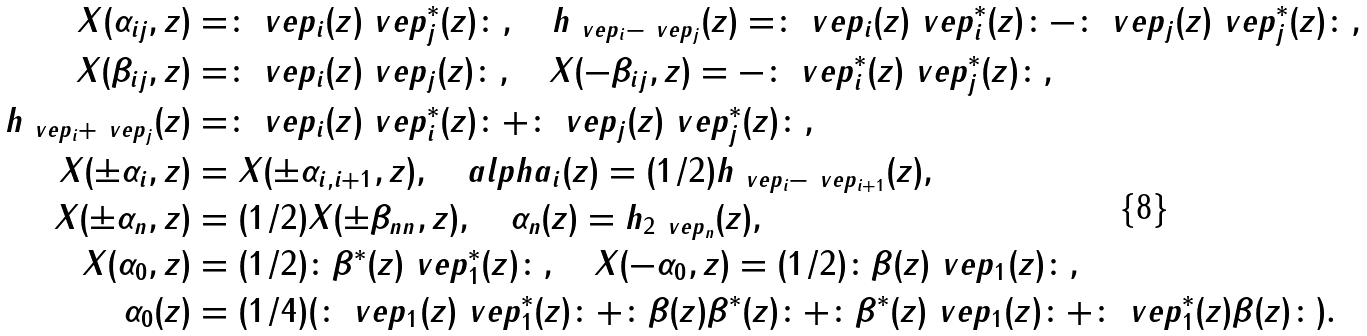Convert formula to latex. <formula><loc_0><loc_0><loc_500><loc_500>X ( \alpha _ { i j } , z ) & = \colon \ v e p _ { i } ( z ) \ v e p _ { j } ^ { * } ( z ) \colon , \quad h _ { \ v e p _ { i } - \ v e p _ { j } } ( z ) = \colon \ v e p _ { i } ( z ) \ v e p _ { i } ^ { * } ( z ) \colon - \colon \ v e p _ { j } ( z ) \ v e p _ { j } ^ { * } ( z ) \colon , \\ X ( \beta _ { i j } , z ) & = \colon \ v e p _ { i } ( z ) \ v e p _ { j } ( z ) \colon , \quad X ( - \beta _ { i j } , z ) = - \colon \ v e p _ { i } ^ { * } ( z ) \ v e p _ { j } ^ { * } ( z ) \colon , \\ h _ { \ v e p _ { i } + \ v e p _ { j } } ( z ) & = \colon \ v e p _ { i } ( z ) \ v e p _ { i } ^ { * } ( z ) \colon + \colon \ v e p _ { j } ( z ) \ v e p _ { j } ^ { * } ( z ) \colon , \\ X ( \pm \alpha _ { i } , z ) & = X ( \pm \alpha _ { i , i + 1 } , z ) , \quad a l p h a _ { i } ( z ) = ( 1 / 2 ) h _ { \ v e p _ { i } - \ v e p _ { i + 1 } } ( z ) , \\ X ( \pm \alpha _ { n } , z ) & = ( 1 / 2 ) X ( \pm \beta _ { n n } , z ) , \quad \alpha _ { n } ( z ) = h _ { 2 \ v e p _ { n } } ( z ) , \\ X ( \alpha _ { 0 } , z ) & = ( 1 / 2 ) \colon \beta ^ { * } ( z ) \ v e p _ { 1 } ^ { * } ( z ) \colon , \quad X ( - \alpha _ { 0 } , z ) = ( 1 / 2 ) \colon \beta ( z ) \ v e p _ { 1 } ( z ) \colon , \\ \alpha _ { 0 } ( z ) & = ( 1 / 4 ) ( \colon \ v e p _ { 1 } ( z ) \ v e p _ { 1 } ^ { * } ( z ) \colon + \colon \beta ( z ) \beta ^ { * } ( z ) \colon + \colon \beta ^ { * } ( z ) \ v e p _ { 1 } ( z ) \colon + \colon \ v e p _ { 1 } ^ { * } ( z ) \beta ( z ) \colon ) . \\</formula> 